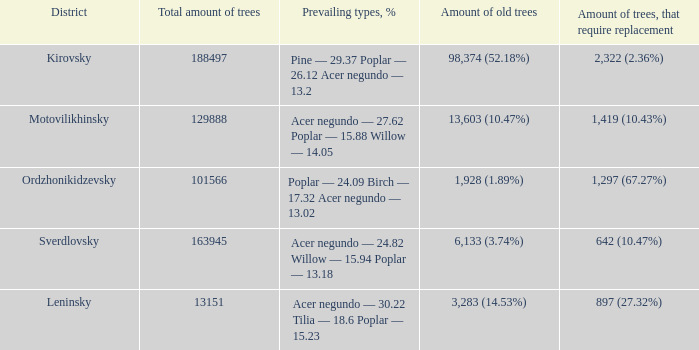Can you give me this table as a dict? {'header': ['District', 'Total amount of trees', 'Prevailing types, %', 'Amount of old trees', 'Amount of trees, that require replacement'], 'rows': [['Kirovsky', '188497', 'Pine — 29.37 Poplar — 26.12 Acer negundo — 13.2', '98,374 (52.18%)', '2,322 (2.36%)'], ['Motovilikhinsky', '129888', 'Acer negundo — 27.62 Poplar — 15.88 Willow — 14.05', '13,603 (10.47%)', '1,419 (10.43%)'], ['Ordzhonikidzevsky', '101566', 'Poplar — 24.09 Birch — 17.32 Acer negundo — 13.02', '1,928 (1.89%)', '1,297 (67.27%)'], ['Sverdlovsky', '163945', 'Acer negundo — 24.82 Willow — 15.94 Poplar — 13.18', '6,133 (3.74%)', '642 (10.47%)'], ['Leninsky', '13151', 'Acer negundo — 30.22 Tilia — 18.6 Poplar — 15.23', '3,283 (14.53%)', '897 (27.32%)']]} What is the total amount of trees when district is leninsky? 13151.0. 